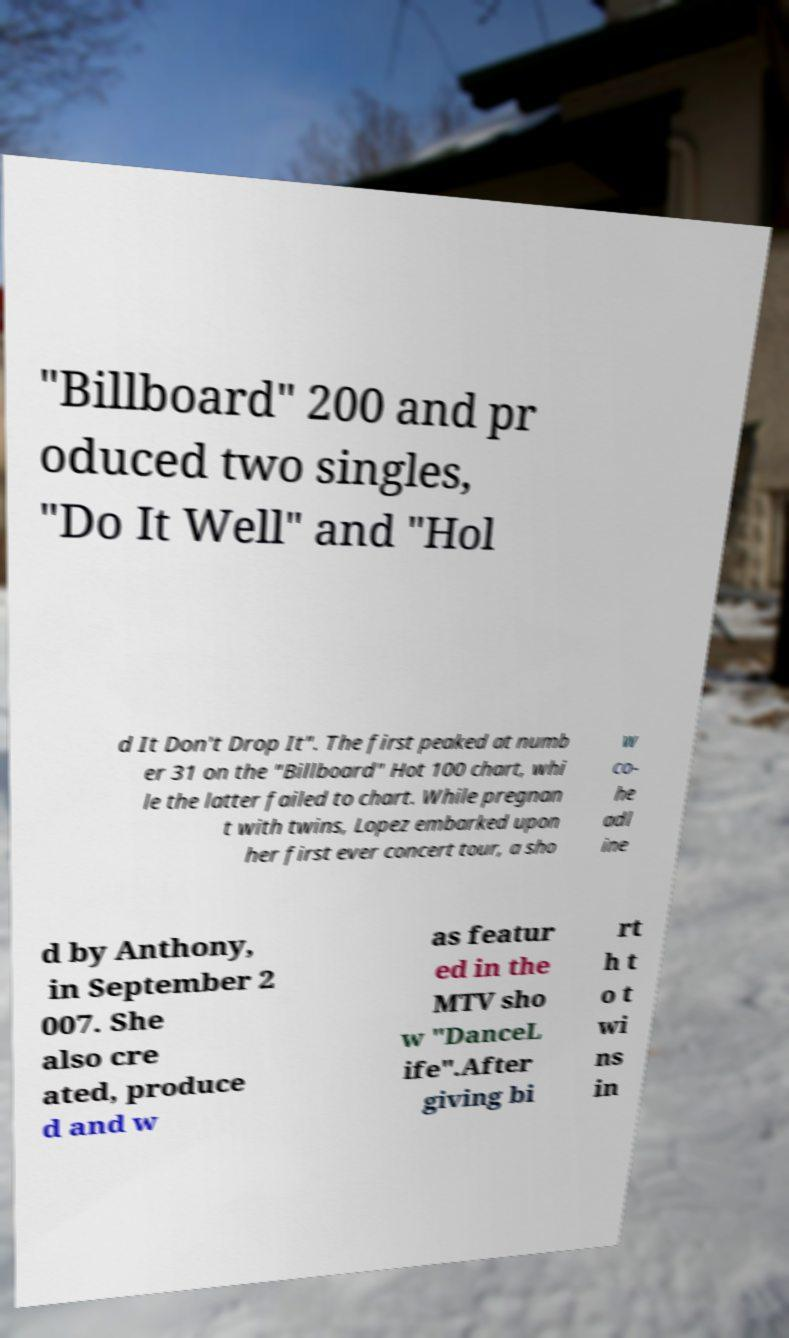Please read and relay the text visible in this image. What does it say? "Billboard" 200 and pr oduced two singles, "Do It Well" and "Hol d It Don't Drop It". The first peaked at numb er 31 on the "Billboard" Hot 100 chart, whi le the latter failed to chart. While pregnan t with twins, Lopez embarked upon her first ever concert tour, a sho w co- he adl ine d by Anthony, in September 2 007. She also cre ated, produce d and w as featur ed in the MTV sho w "DanceL ife".After giving bi rt h t o t wi ns in 